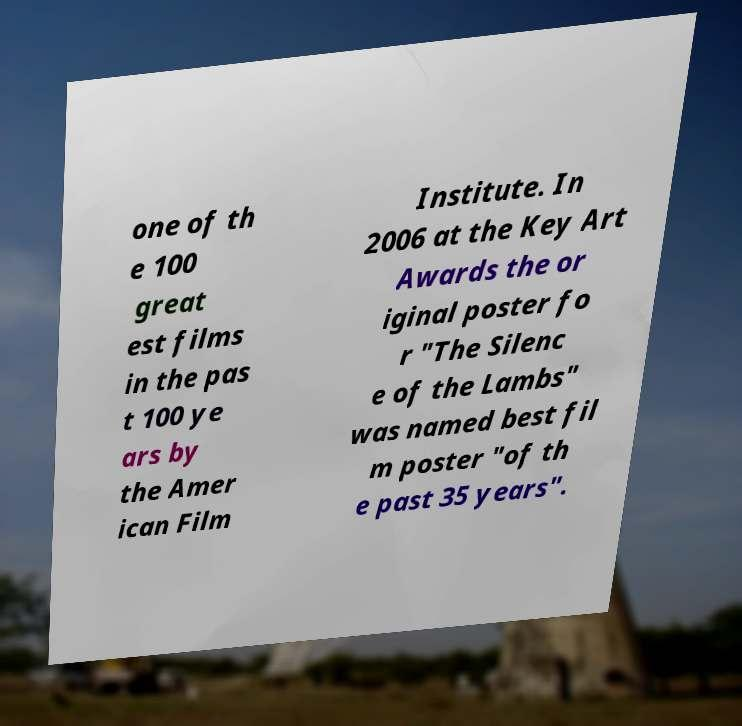For documentation purposes, I need the text within this image transcribed. Could you provide that? one of th e 100 great est films in the pas t 100 ye ars by the Amer ican Film Institute. In 2006 at the Key Art Awards the or iginal poster fo r "The Silenc e of the Lambs" was named best fil m poster "of th e past 35 years". 